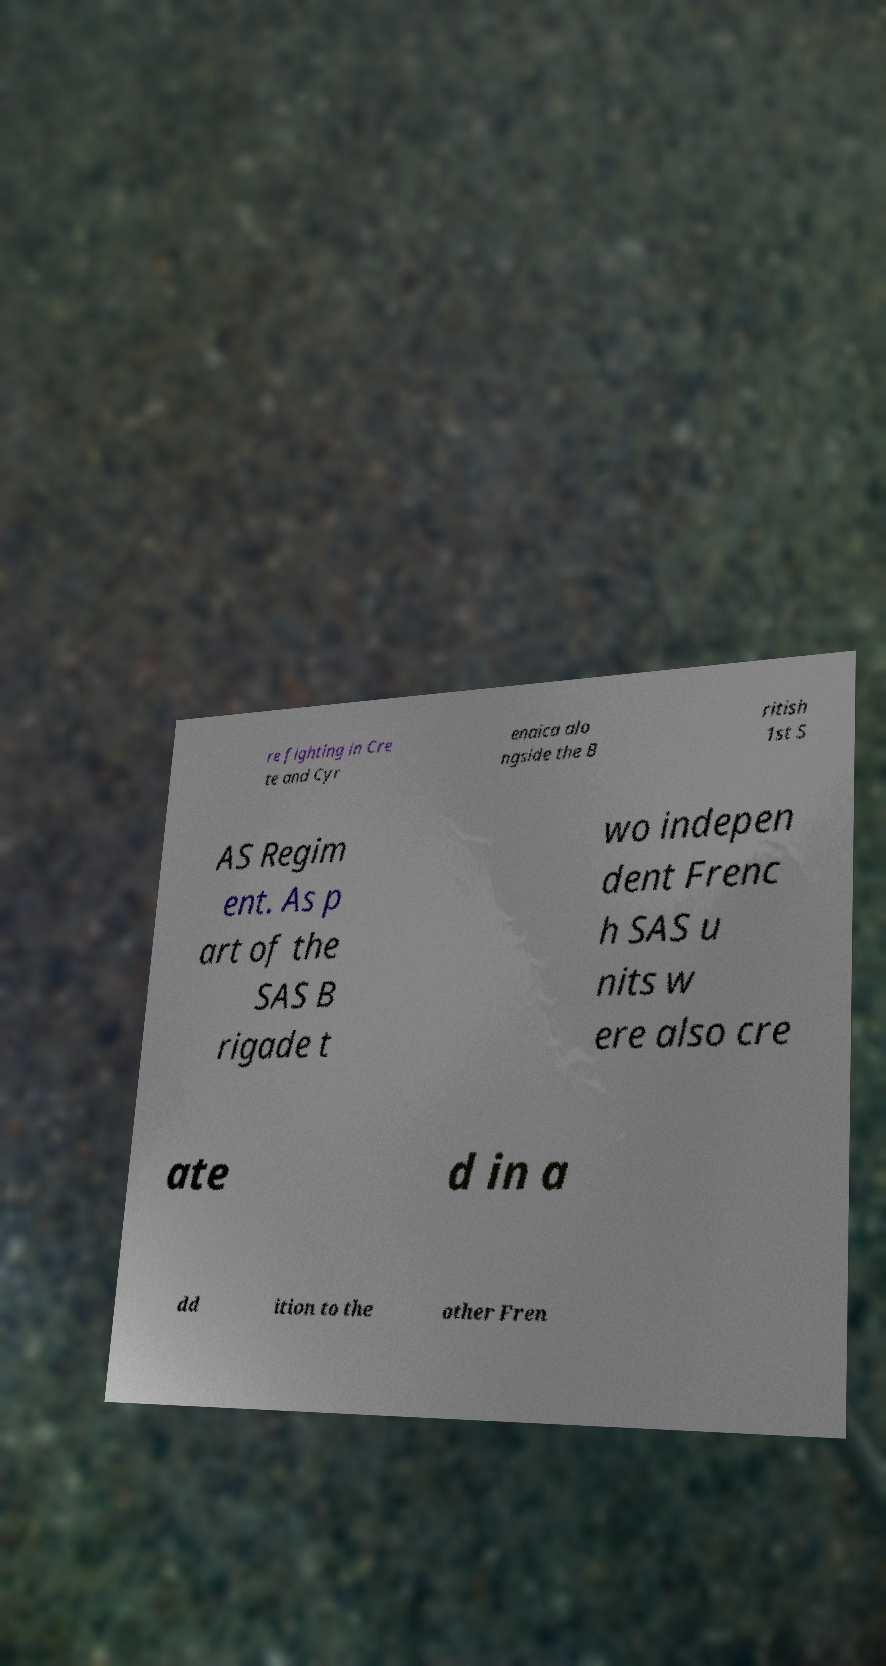Can you read and provide the text displayed in the image?This photo seems to have some interesting text. Can you extract and type it out for me? re fighting in Cre te and Cyr enaica alo ngside the B ritish 1st S AS Regim ent. As p art of the SAS B rigade t wo indepen dent Frenc h SAS u nits w ere also cre ate d in a dd ition to the other Fren 